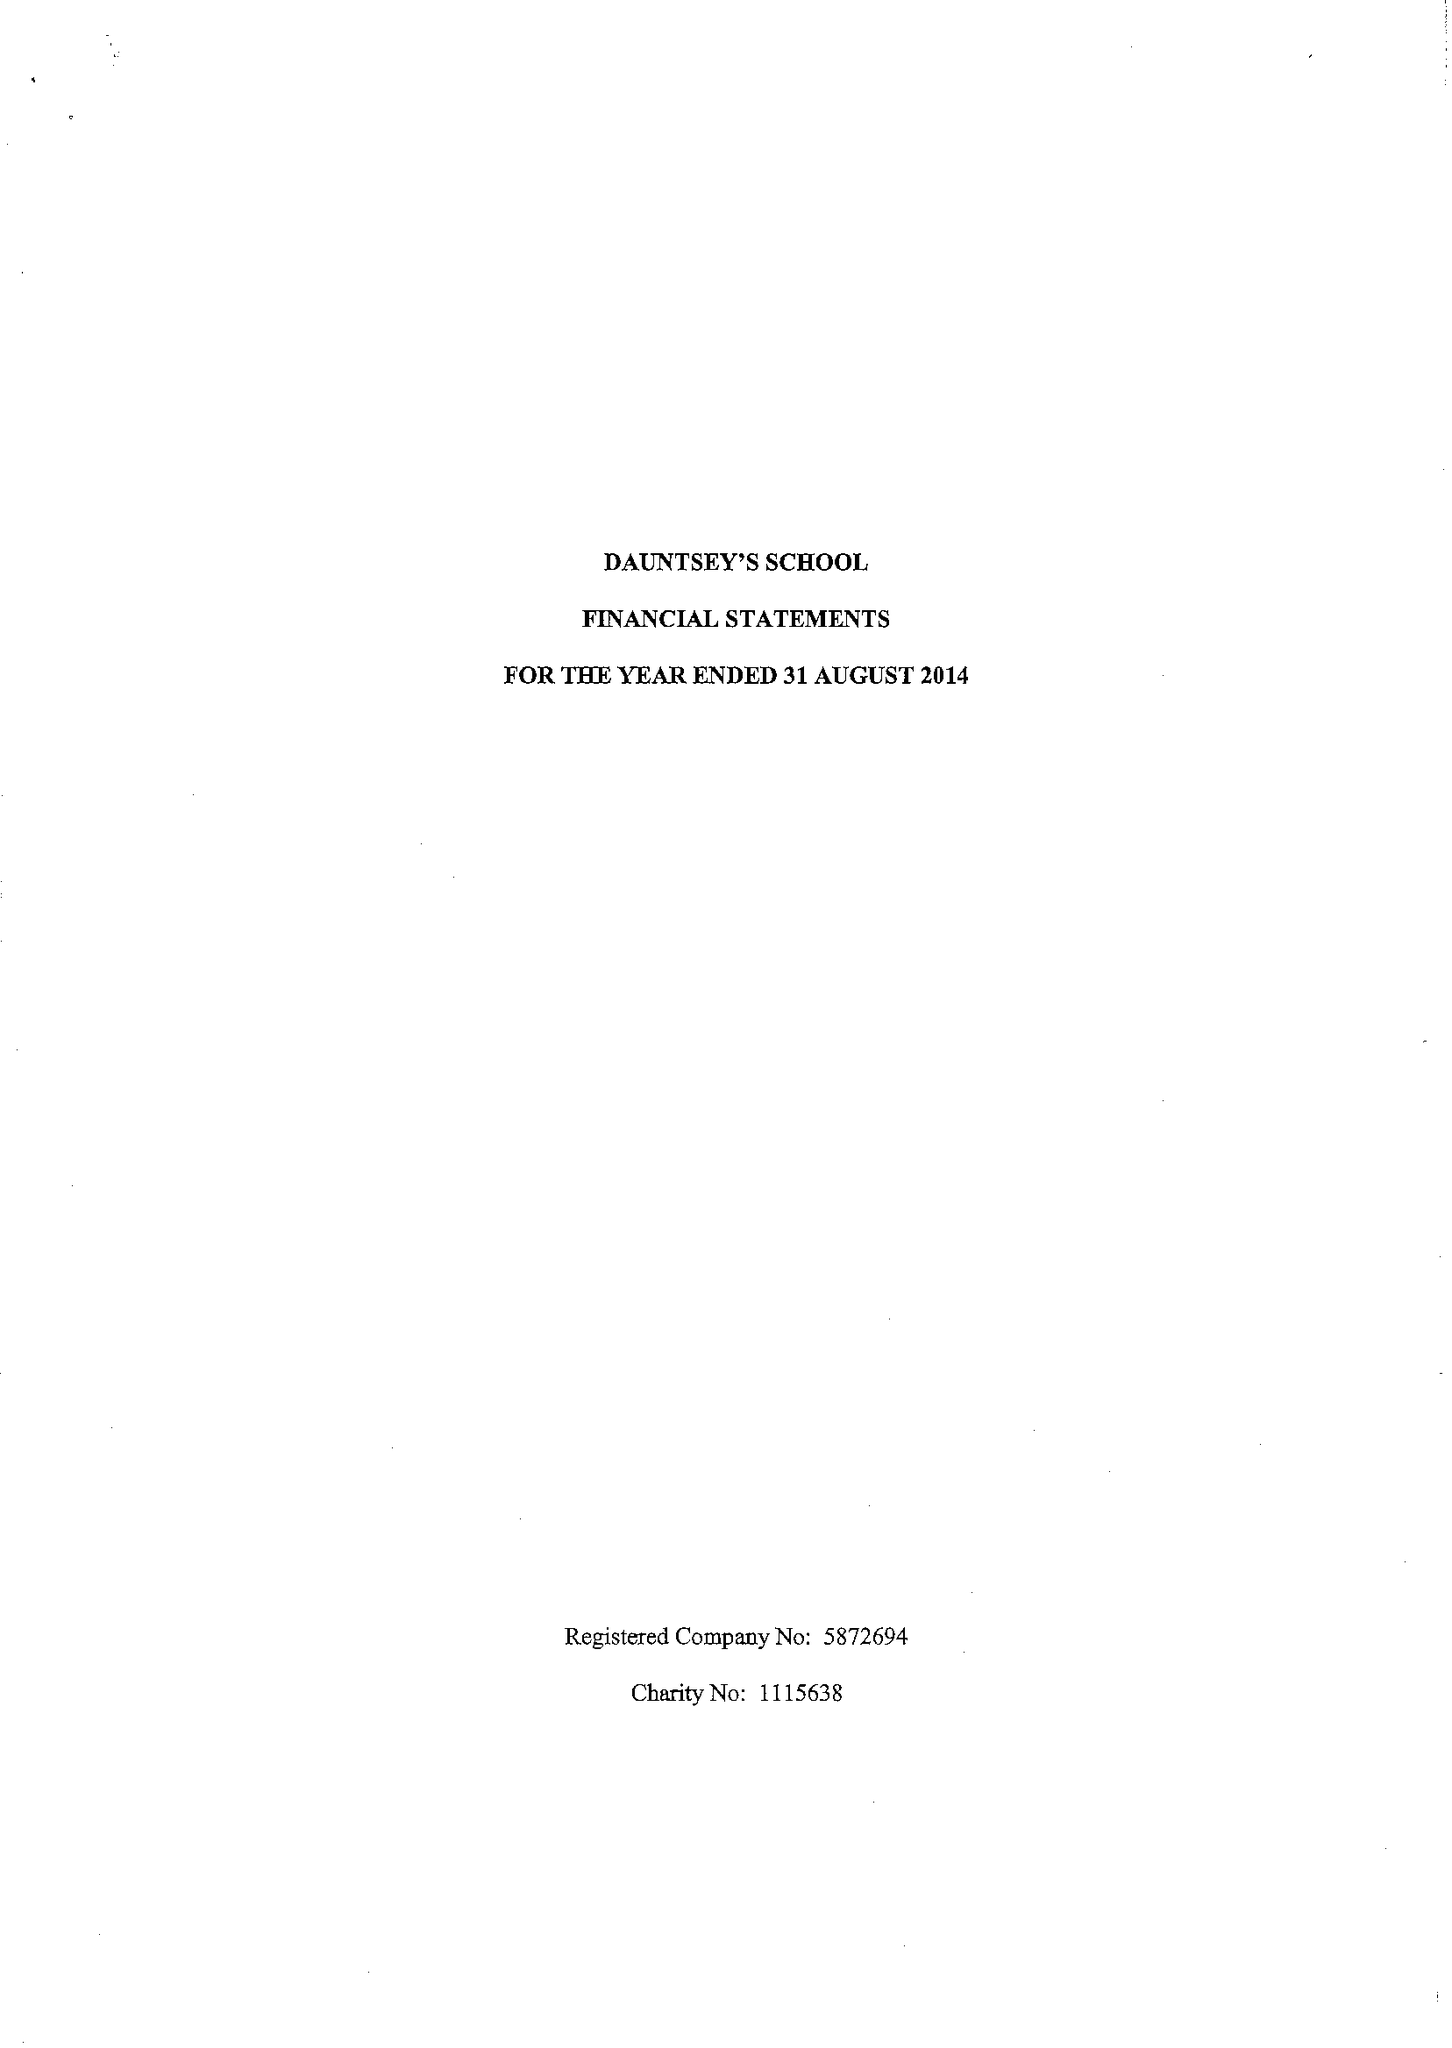What is the value for the address__post_town?
Answer the question using a single word or phrase. DEVIZES 